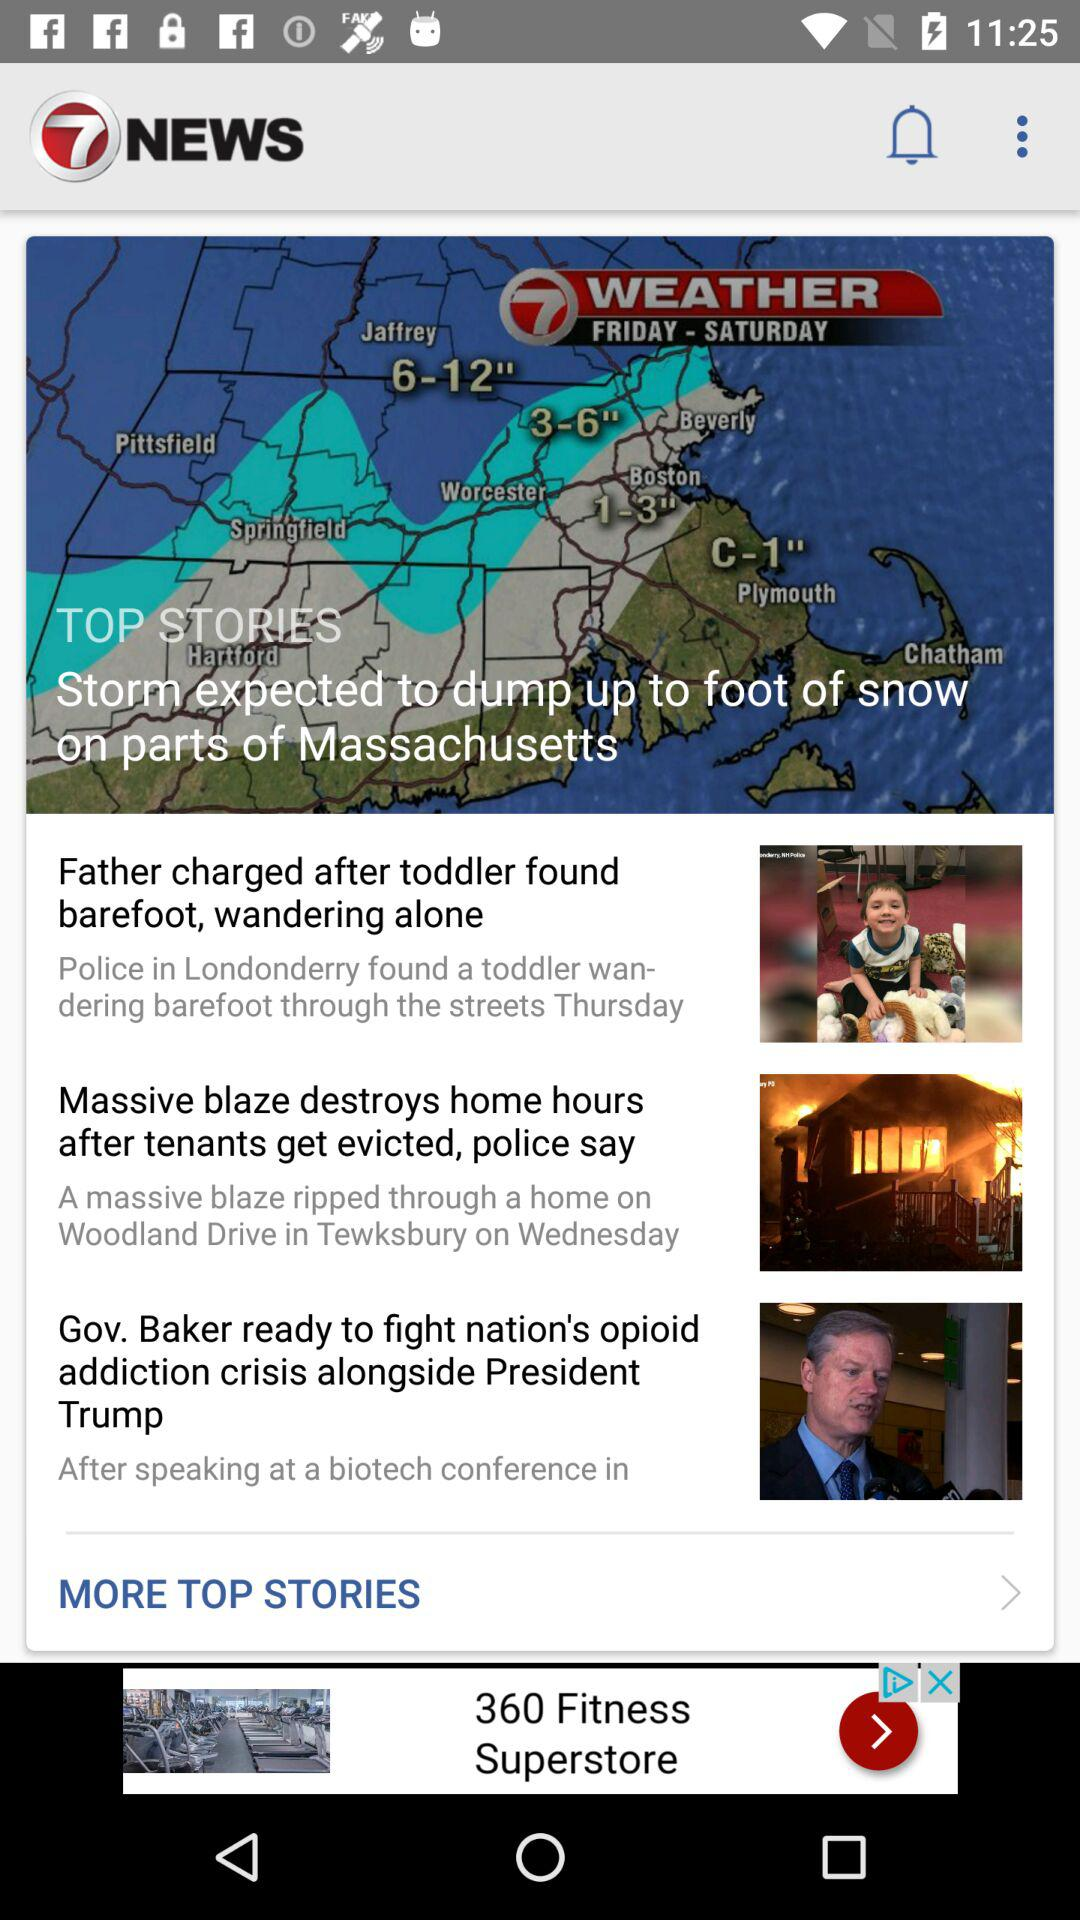How many more stories are there after the first story?
Answer the question using a single word or phrase. 2 